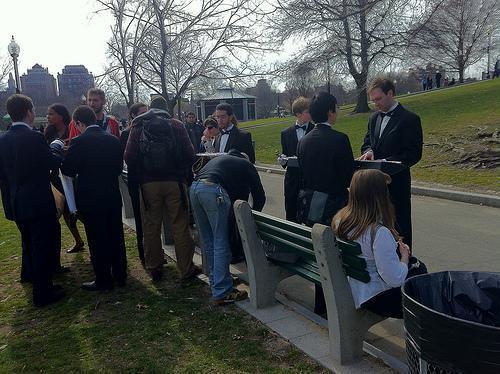How many people are sitting?
Give a very brief answer. 1. How many men are holding trays?
Give a very brief answer. 3. 